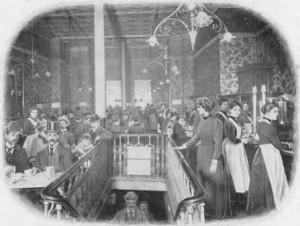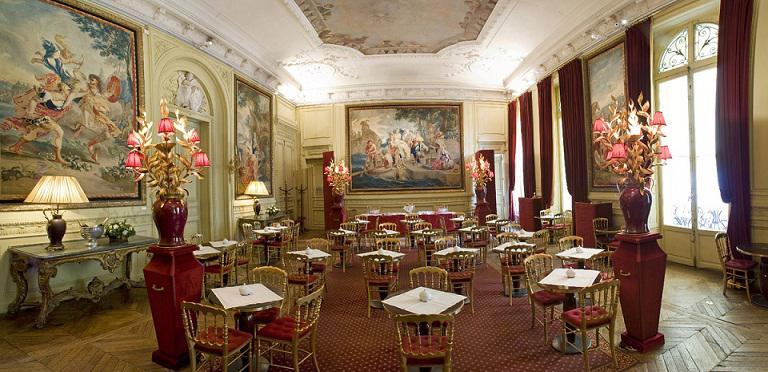The first image is the image on the left, the second image is the image on the right. For the images shown, is this caption "The left image shows two people seated at a small table set with coffee cups, and a person standing behind them." true? Answer yes or no. No. 